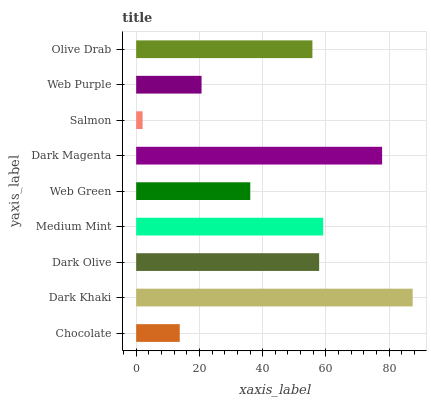Is Salmon the minimum?
Answer yes or no. Yes. Is Dark Khaki the maximum?
Answer yes or no. Yes. Is Dark Olive the minimum?
Answer yes or no. No. Is Dark Olive the maximum?
Answer yes or no. No. Is Dark Khaki greater than Dark Olive?
Answer yes or no. Yes. Is Dark Olive less than Dark Khaki?
Answer yes or no. Yes. Is Dark Olive greater than Dark Khaki?
Answer yes or no. No. Is Dark Khaki less than Dark Olive?
Answer yes or no. No. Is Olive Drab the high median?
Answer yes or no. Yes. Is Olive Drab the low median?
Answer yes or no. Yes. Is Dark Magenta the high median?
Answer yes or no. No. Is Salmon the low median?
Answer yes or no. No. 